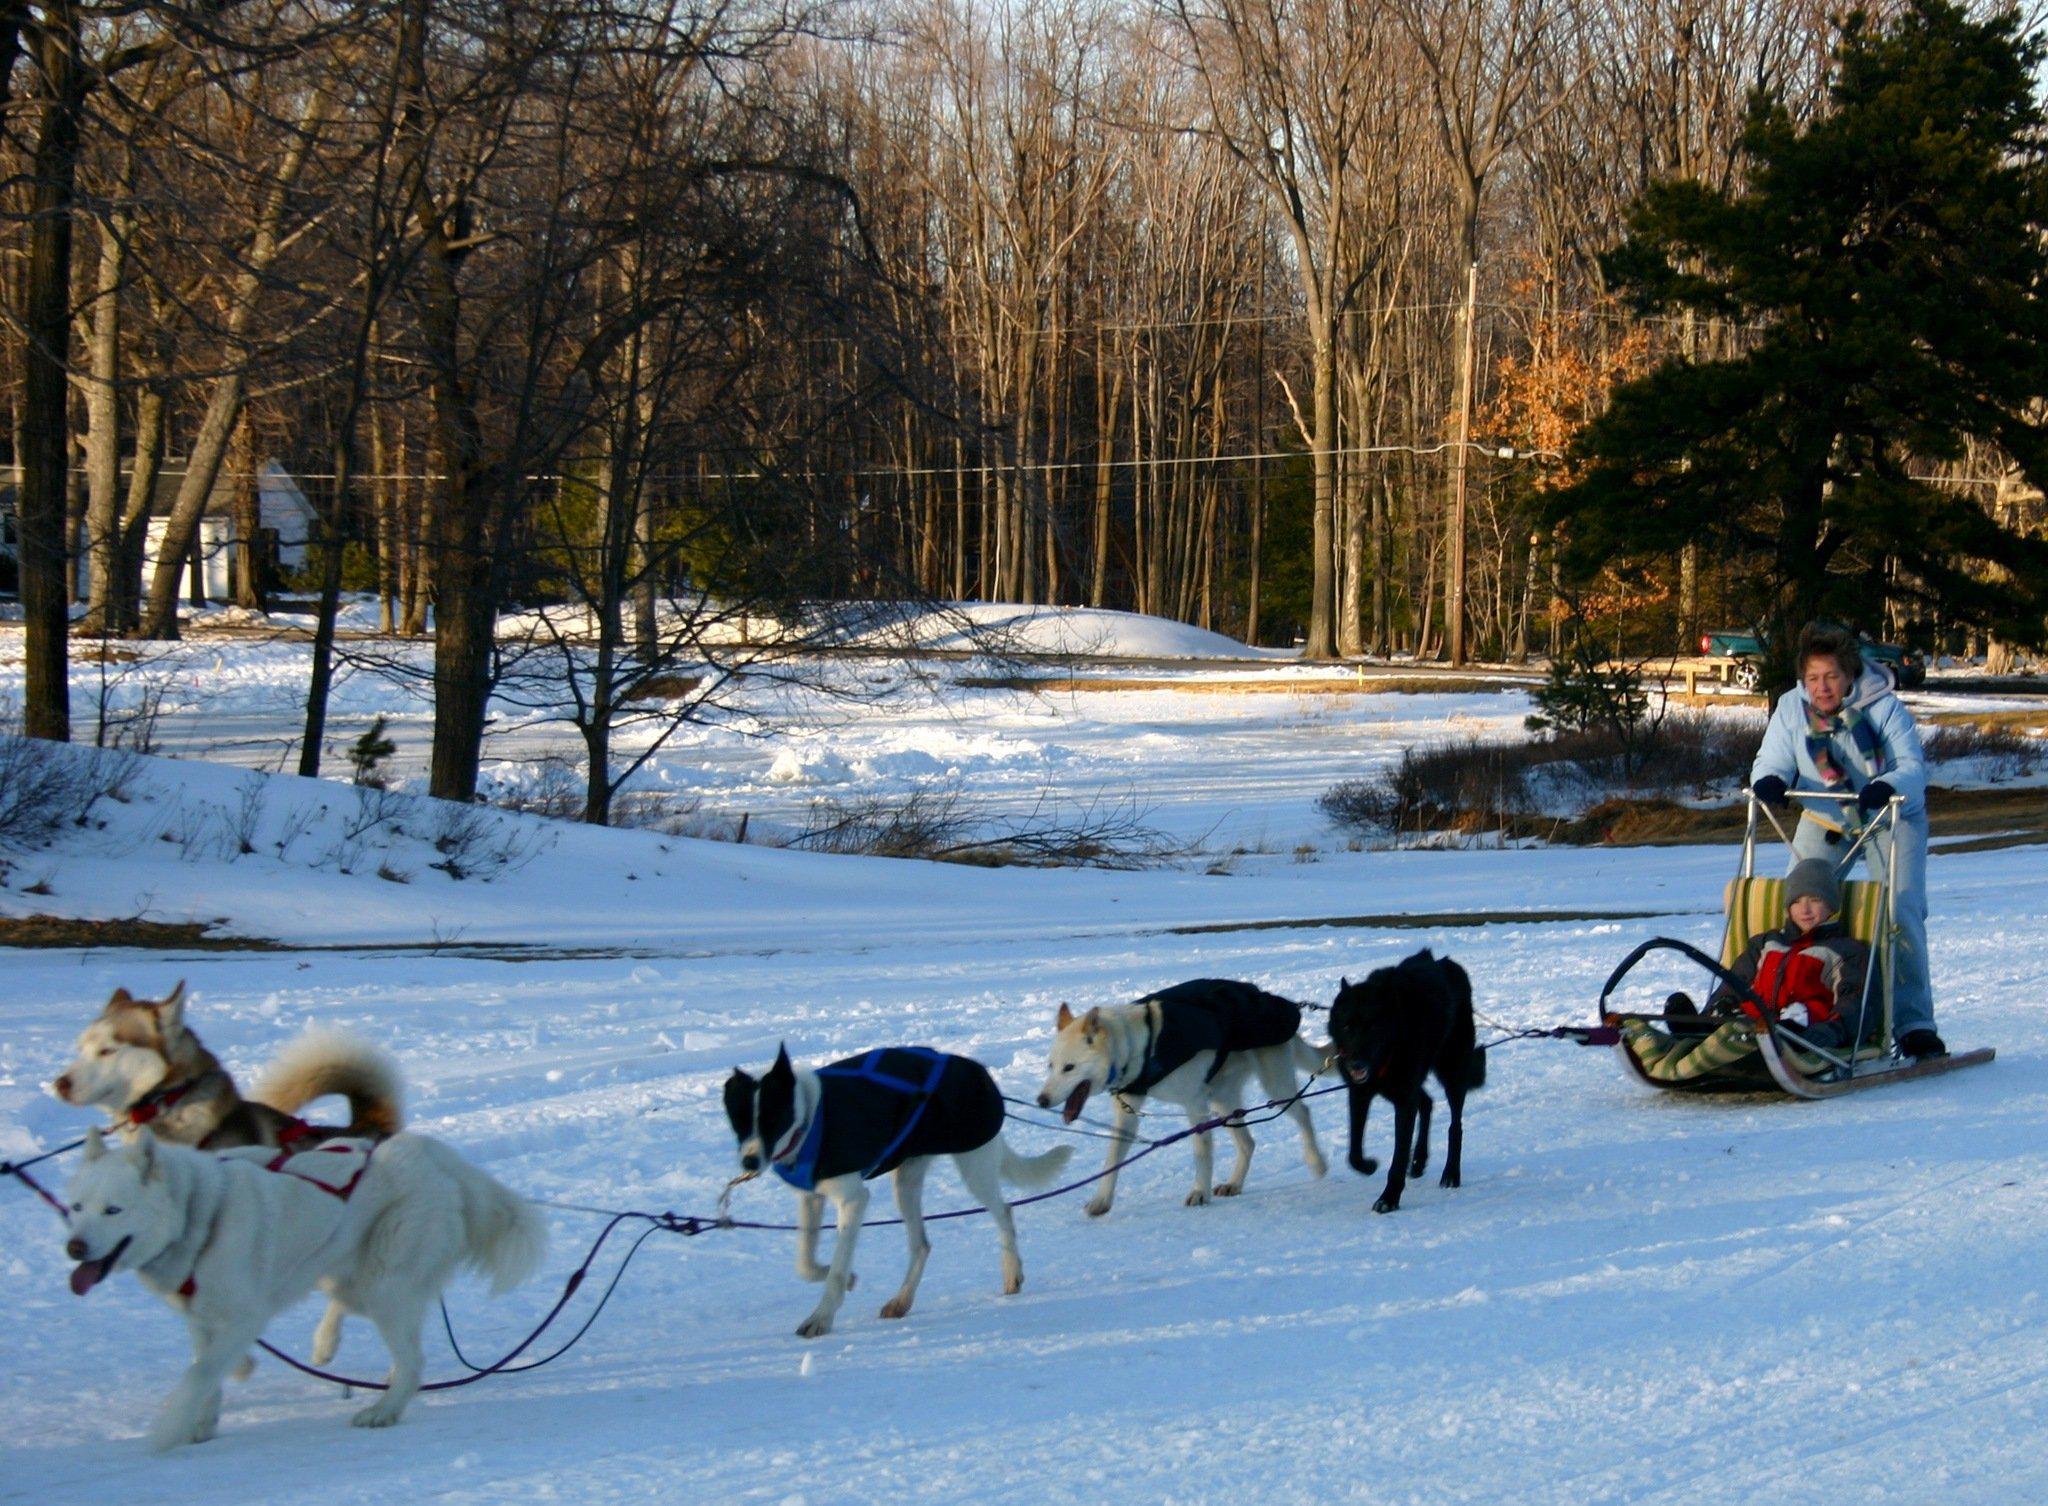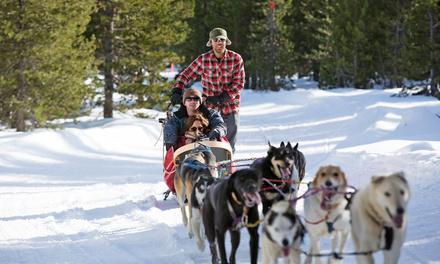The first image is the image on the left, the second image is the image on the right. Considering the images on both sides, is "There are two huskies strapped next to each other on the snow." valid? Answer yes or no. No. The first image is the image on the left, the second image is the image on the right. Considering the images on both sides, is "In the right image, crowds of people are standing behind a dog sled team driven by a man in a vest and headed forward." valid? Answer yes or no. No. 